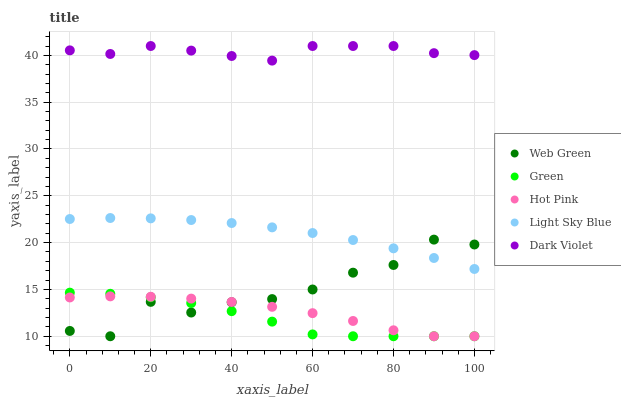Does Green have the minimum area under the curve?
Answer yes or no. Yes. Does Dark Violet have the maximum area under the curve?
Answer yes or no. Yes. Does Dark Violet have the minimum area under the curve?
Answer yes or no. No. Does Green have the maximum area under the curve?
Answer yes or no. No. Is Light Sky Blue the smoothest?
Answer yes or no. Yes. Is Web Green the roughest?
Answer yes or no. Yes. Is Green the smoothest?
Answer yes or no. No. Is Green the roughest?
Answer yes or no. No. Does Hot Pink have the lowest value?
Answer yes or no. Yes. Does Dark Violet have the lowest value?
Answer yes or no. No. Does Dark Violet have the highest value?
Answer yes or no. Yes. Does Green have the highest value?
Answer yes or no. No. Is Green less than Dark Violet?
Answer yes or no. Yes. Is Dark Violet greater than Light Sky Blue?
Answer yes or no. Yes. Does Light Sky Blue intersect Web Green?
Answer yes or no. Yes. Is Light Sky Blue less than Web Green?
Answer yes or no. No. Is Light Sky Blue greater than Web Green?
Answer yes or no. No. Does Green intersect Dark Violet?
Answer yes or no. No. 